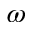<formula> <loc_0><loc_0><loc_500><loc_500>\omega</formula> 